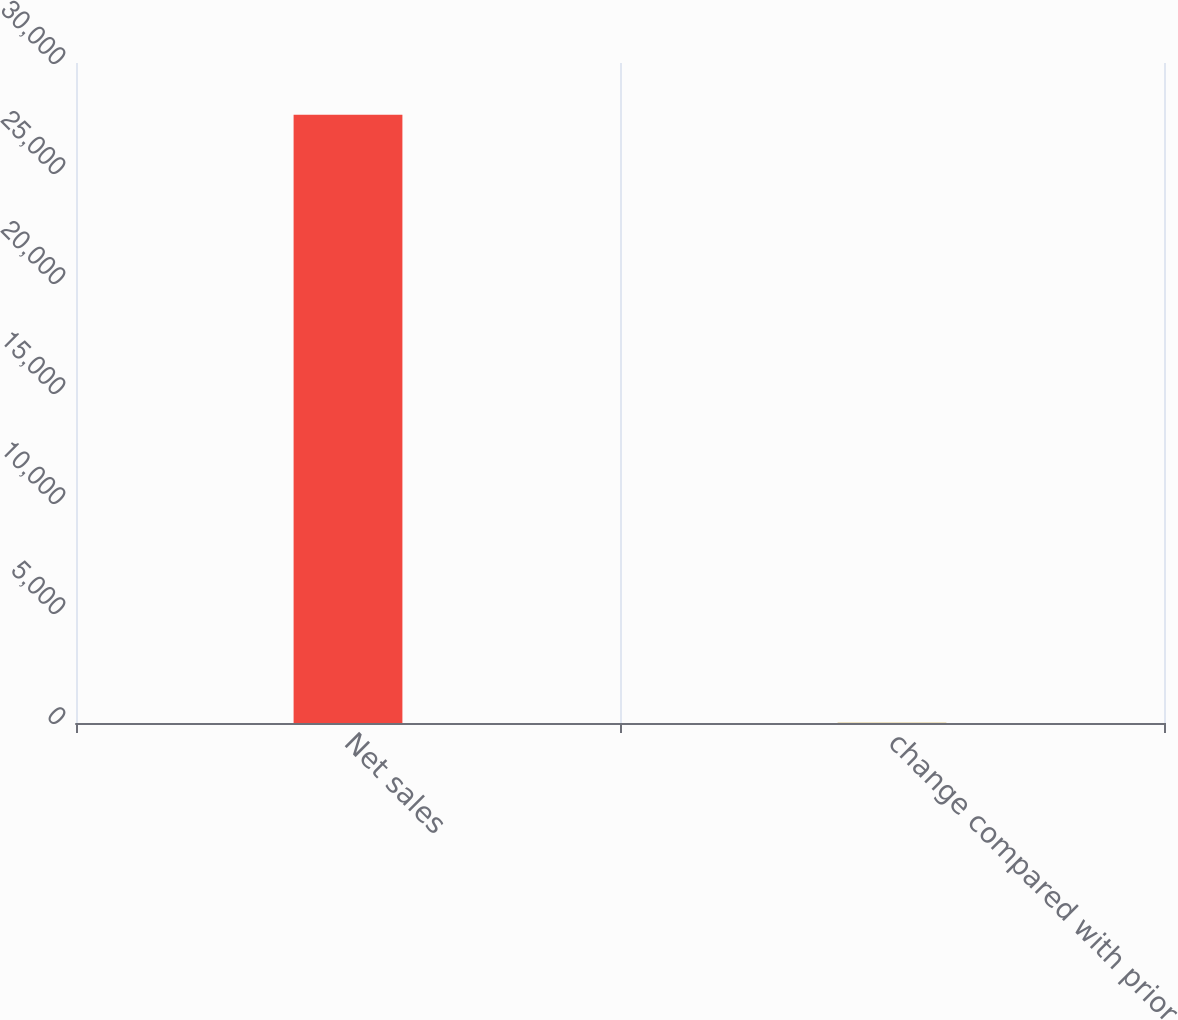Convert chart. <chart><loc_0><loc_0><loc_500><loc_500><bar_chart><fcel>Net sales<fcel>change compared with prior<nl><fcel>27653<fcel>8<nl></chart> 